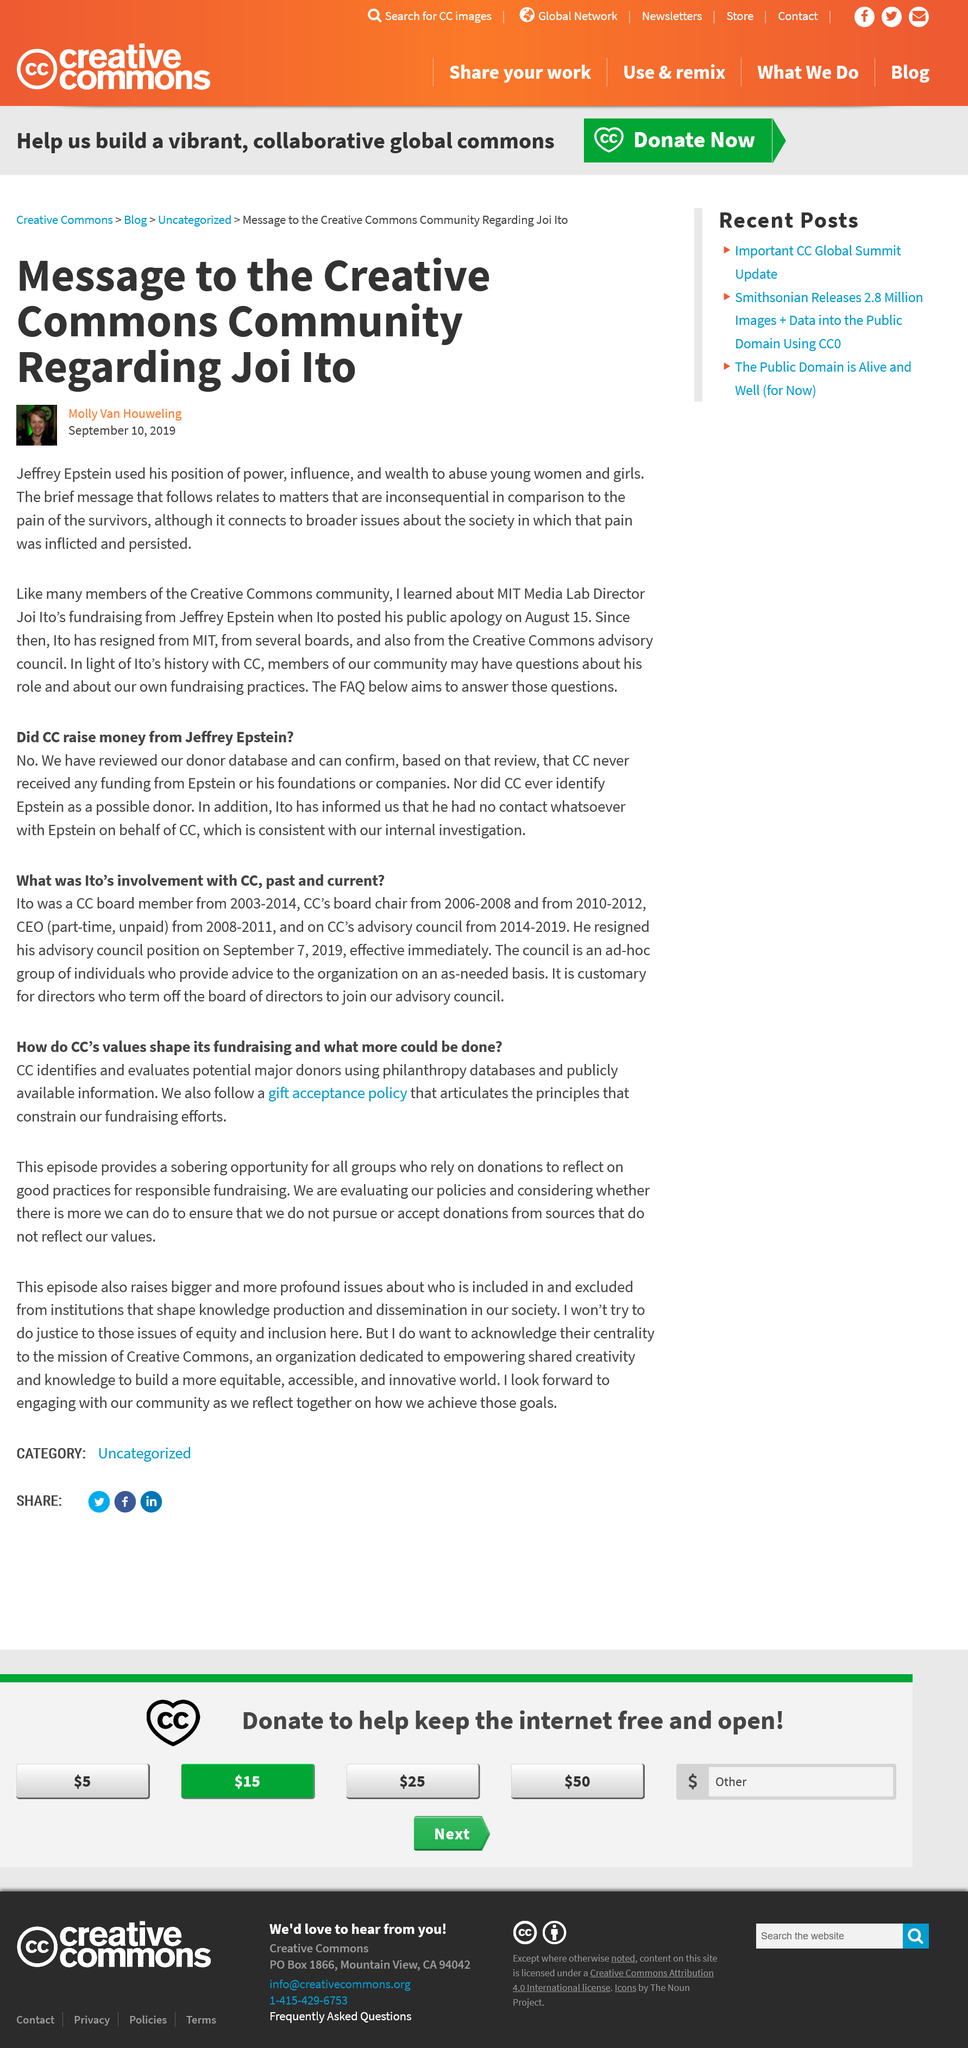Give some essential details in this illustration. Jeffery Epstein committed the crime of abusing young women and girls. Jeffrey Eppstein rightly pointed blame on Joi Ito. The person/company in question follows a gift acceptance policy. Joi Ito, who was the Media Lab Director at MIT, held a specific position at the institution. CC uses philanthropy databases and publicly available information to identify and evaluate potential major donors for evaluation. 